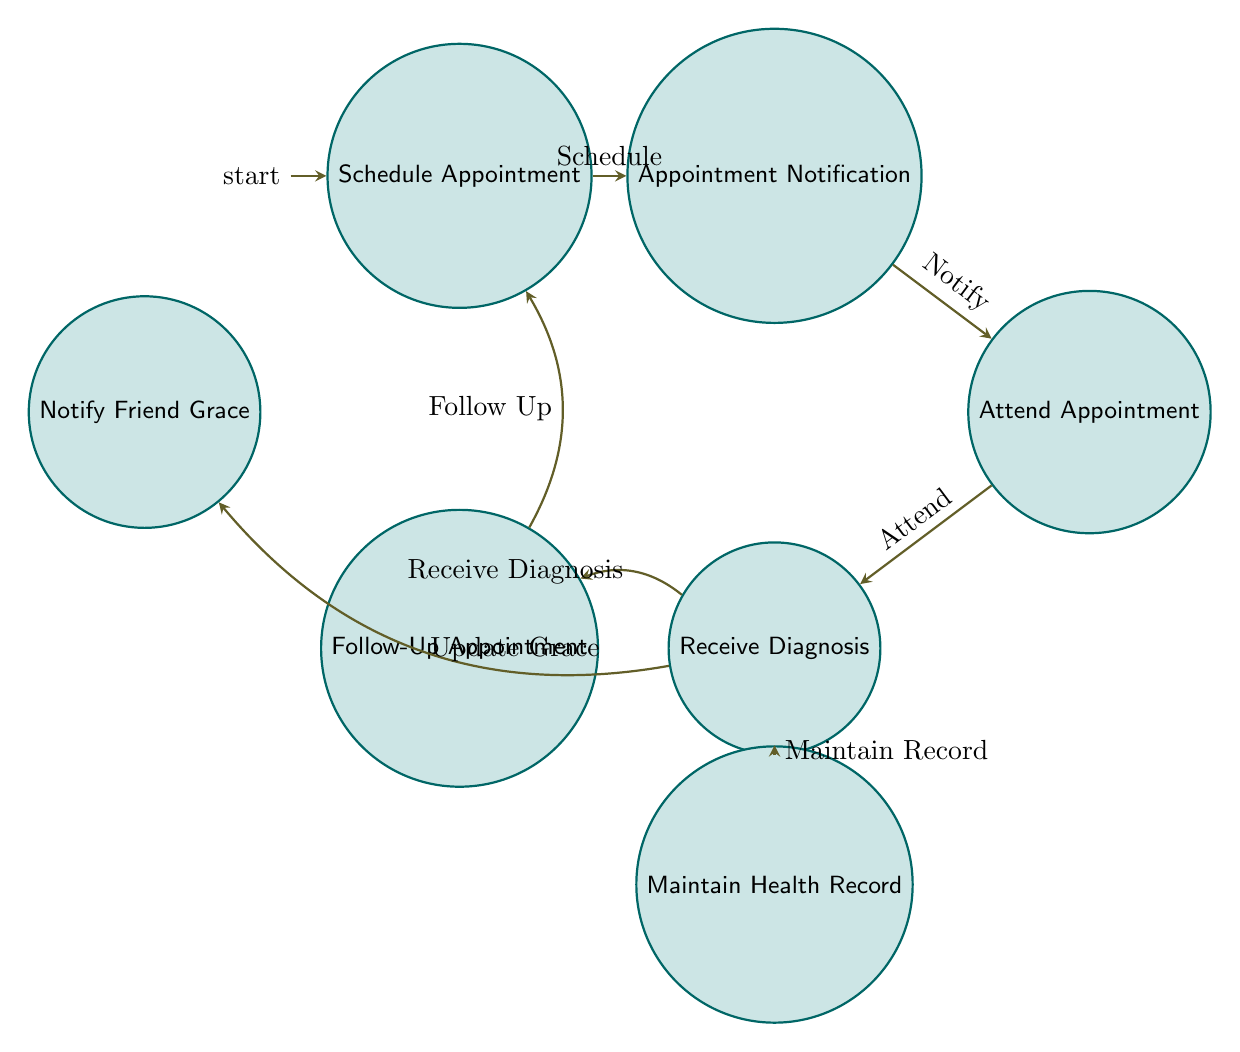What is the initial state of the Finite State Machine? The initial state is indicated by the "initial" marker next to one of the nodes, which is "Schedule Appointment."
Answer: Schedule Appointment How many states are there in the diagram? The number of states can be calculated by counting each unique node present in the diagram. There are seven states given in the data.
Answer: 7 What event leads from "Appointment Notification" to "Attend Appointment"? The transition from "Appointment Notification" to "Attend Appointment" is indicated by the edge labeled with the event "Notify."
Answer: Notify What state follows "Receive Diagnosis And Recommendations" when the event "Follow Up" occurs? The event "Follow Up" connects "Receive Diagnosis And Recommendations" to "Follow-Up Appointment," as shown in the transition arrow.
Answer: Follow-Up Appointment After attending an appointment, which state is next according to the diagram? The transition after "Attend Appointment" goes to "Receive Diagnosis And Recommendations," indicating this is the next state in the flow.
Answer: Receive Diagnosis And Recommendations If a patient wants to notify Grace about their health, which state would they enter after "Receive Diagnosis And Recommendations"? The event "Update Grace" leads to the state "Notify Friend Grace," indicating this is the course of action to notify Grace about health status.
Answer: Notify Friend Grace How many transitions are there in the diagram? The total number of transitions can be found by counting each directed arrow between states provided in the data. There are six transitions listed.
Answer: 6 Which states can be accessed directly from "Receive Diagnosis And Recommendations"? Two edges emanate from "Receive Diagnosis And Recommendations," leading to "Follow-Up Appointment" and "Notify Friend Grace," meaning both of these states can be accessed directly from it.
Answer: Follow-Up Appointment, Notify Friend Grace What is the final node a patient reaches after following the health check-up flow? The flow continues in a circular pattern, ultimately returning to "Schedule Appointment" after a follow-up, indicating that it is a recurring process.
Answer: Schedule Appointment 